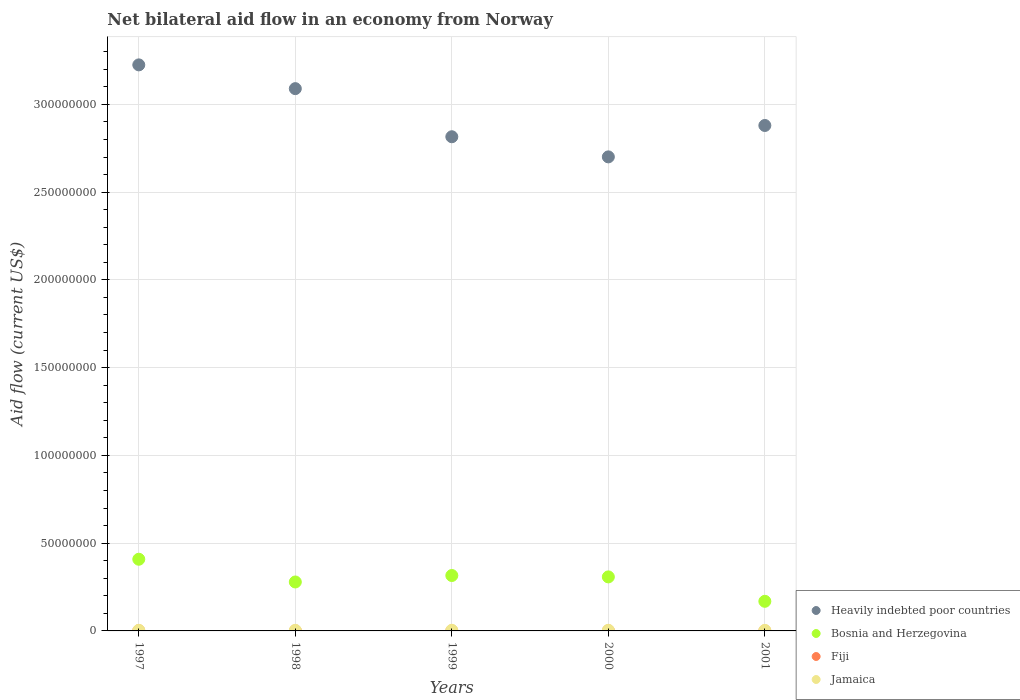How many different coloured dotlines are there?
Make the answer very short. 4. Is the number of dotlines equal to the number of legend labels?
Your answer should be compact. Yes. Across all years, what is the minimum net bilateral aid flow in Fiji?
Your answer should be compact. 2.00e+04. In which year was the net bilateral aid flow in Fiji maximum?
Your answer should be very brief. 1997. In which year was the net bilateral aid flow in Jamaica minimum?
Offer a very short reply. 2001. What is the difference between the net bilateral aid flow in Jamaica in 1997 and that in 1999?
Offer a very short reply. -2.00e+04. What is the difference between the net bilateral aid flow in Heavily indebted poor countries in 1999 and the net bilateral aid flow in Bosnia and Herzegovina in 2001?
Your response must be concise. 2.65e+08. What is the average net bilateral aid flow in Bosnia and Herzegovina per year?
Offer a terse response. 2.96e+07. In the year 2001, what is the difference between the net bilateral aid flow in Bosnia and Herzegovina and net bilateral aid flow in Heavily indebted poor countries?
Give a very brief answer. -2.71e+08. What is the ratio of the net bilateral aid flow in Jamaica in 1999 to that in 2001?
Provide a succinct answer. 1.16. Is the difference between the net bilateral aid flow in Bosnia and Herzegovina in 1998 and 1999 greater than the difference between the net bilateral aid flow in Heavily indebted poor countries in 1998 and 1999?
Your response must be concise. No. What is the difference between the highest and the second highest net bilateral aid flow in Heavily indebted poor countries?
Offer a terse response. 1.35e+07. What is the difference between the highest and the lowest net bilateral aid flow in Bosnia and Herzegovina?
Your response must be concise. 2.40e+07. Is it the case that in every year, the sum of the net bilateral aid flow in Jamaica and net bilateral aid flow in Heavily indebted poor countries  is greater than the sum of net bilateral aid flow in Fiji and net bilateral aid flow in Bosnia and Herzegovina?
Offer a very short reply. No. Is it the case that in every year, the sum of the net bilateral aid flow in Fiji and net bilateral aid flow in Bosnia and Herzegovina  is greater than the net bilateral aid flow in Heavily indebted poor countries?
Your response must be concise. No. Does the net bilateral aid flow in Bosnia and Herzegovina monotonically increase over the years?
Your answer should be compact. No. Is the net bilateral aid flow in Heavily indebted poor countries strictly greater than the net bilateral aid flow in Bosnia and Herzegovina over the years?
Offer a terse response. Yes. Is the net bilateral aid flow in Jamaica strictly less than the net bilateral aid flow in Heavily indebted poor countries over the years?
Offer a very short reply. Yes. How many dotlines are there?
Ensure brevity in your answer.  4. How many years are there in the graph?
Your answer should be very brief. 5. Does the graph contain grids?
Offer a very short reply. Yes. Where does the legend appear in the graph?
Offer a very short reply. Bottom right. What is the title of the graph?
Your response must be concise. Net bilateral aid flow in an economy from Norway. Does "Gambia, The" appear as one of the legend labels in the graph?
Your answer should be compact. No. What is the label or title of the X-axis?
Ensure brevity in your answer.  Years. What is the label or title of the Y-axis?
Make the answer very short. Aid flow (current US$). What is the Aid flow (current US$) in Heavily indebted poor countries in 1997?
Make the answer very short. 3.23e+08. What is the Aid flow (current US$) in Bosnia and Herzegovina in 1997?
Your answer should be compact. 4.08e+07. What is the Aid flow (current US$) in Fiji in 1997?
Give a very brief answer. 1.30e+05. What is the Aid flow (current US$) in Jamaica in 1997?
Ensure brevity in your answer.  3.40e+05. What is the Aid flow (current US$) in Heavily indebted poor countries in 1998?
Your answer should be compact. 3.09e+08. What is the Aid flow (current US$) of Bosnia and Herzegovina in 1998?
Your answer should be compact. 2.79e+07. What is the Aid flow (current US$) in Fiji in 1998?
Provide a short and direct response. 2.00e+04. What is the Aid flow (current US$) of Heavily indebted poor countries in 1999?
Offer a very short reply. 2.82e+08. What is the Aid flow (current US$) of Bosnia and Herzegovina in 1999?
Offer a very short reply. 3.16e+07. What is the Aid flow (current US$) in Fiji in 1999?
Ensure brevity in your answer.  2.00e+04. What is the Aid flow (current US$) of Jamaica in 1999?
Your response must be concise. 3.60e+05. What is the Aid flow (current US$) in Heavily indebted poor countries in 2000?
Make the answer very short. 2.70e+08. What is the Aid flow (current US$) of Bosnia and Herzegovina in 2000?
Your answer should be compact. 3.08e+07. What is the Aid flow (current US$) in Fiji in 2000?
Your response must be concise. 1.00e+05. What is the Aid flow (current US$) of Heavily indebted poor countries in 2001?
Keep it short and to the point. 2.88e+08. What is the Aid flow (current US$) of Bosnia and Herzegovina in 2001?
Your response must be concise. 1.69e+07. Across all years, what is the maximum Aid flow (current US$) in Heavily indebted poor countries?
Offer a terse response. 3.23e+08. Across all years, what is the maximum Aid flow (current US$) in Bosnia and Herzegovina?
Provide a short and direct response. 4.08e+07. Across all years, what is the maximum Aid flow (current US$) in Fiji?
Your answer should be compact. 1.30e+05. Across all years, what is the maximum Aid flow (current US$) of Jamaica?
Keep it short and to the point. 3.60e+05. Across all years, what is the minimum Aid flow (current US$) of Heavily indebted poor countries?
Make the answer very short. 2.70e+08. Across all years, what is the minimum Aid flow (current US$) of Bosnia and Herzegovina?
Offer a terse response. 1.69e+07. Across all years, what is the minimum Aid flow (current US$) of Jamaica?
Make the answer very short. 3.10e+05. What is the total Aid flow (current US$) in Heavily indebted poor countries in the graph?
Offer a very short reply. 1.47e+09. What is the total Aid flow (current US$) in Bosnia and Herzegovina in the graph?
Make the answer very short. 1.48e+08. What is the total Aid flow (current US$) of Jamaica in the graph?
Provide a short and direct response. 1.71e+06. What is the difference between the Aid flow (current US$) in Heavily indebted poor countries in 1997 and that in 1998?
Your response must be concise. 1.35e+07. What is the difference between the Aid flow (current US$) of Bosnia and Herzegovina in 1997 and that in 1998?
Your answer should be very brief. 1.30e+07. What is the difference between the Aid flow (current US$) in Fiji in 1997 and that in 1998?
Your answer should be very brief. 1.10e+05. What is the difference between the Aid flow (current US$) of Jamaica in 1997 and that in 1998?
Ensure brevity in your answer.  0. What is the difference between the Aid flow (current US$) in Heavily indebted poor countries in 1997 and that in 1999?
Give a very brief answer. 4.10e+07. What is the difference between the Aid flow (current US$) of Bosnia and Herzegovina in 1997 and that in 1999?
Ensure brevity in your answer.  9.27e+06. What is the difference between the Aid flow (current US$) of Heavily indebted poor countries in 1997 and that in 2000?
Provide a short and direct response. 5.24e+07. What is the difference between the Aid flow (current US$) in Bosnia and Herzegovina in 1997 and that in 2000?
Your response must be concise. 1.01e+07. What is the difference between the Aid flow (current US$) in Fiji in 1997 and that in 2000?
Provide a succinct answer. 3.00e+04. What is the difference between the Aid flow (current US$) of Jamaica in 1997 and that in 2000?
Make the answer very short. -2.00e+04. What is the difference between the Aid flow (current US$) in Heavily indebted poor countries in 1997 and that in 2001?
Keep it short and to the point. 3.45e+07. What is the difference between the Aid flow (current US$) in Bosnia and Herzegovina in 1997 and that in 2001?
Keep it short and to the point. 2.40e+07. What is the difference between the Aid flow (current US$) in Jamaica in 1997 and that in 2001?
Offer a terse response. 3.00e+04. What is the difference between the Aid flow (current US$) of Heavily indebted poor countries in 1998 and that in 1999?
Keep it short and to the point. 2.74e+07. What is the difference between the Aid flow (current US$) of Bosnia and Herzegovina in 1998 and that in 1999?
Your response must be concise. -3.68e+06. What is the difference between the Aid flow (current US$) in Fiji in 1998 and that in 1999?
Offer a very short reply. 0. What is the difference between the Aid flow (current US$) in Jamaica in 1998 and that in 1999?
Your response must be concise. -2.00e+04. What is the difference between the Aid flow (current US$) of Heavily indebted poor countries in 1998 and that in 2000?
Give a very brief answer. 3.89e+07. What is the difference between the Aid flow (current US$) in Bosnia and Herzegovina in 1998 and that in 2000?
Your response must be concise. -2.89e+06. What is the difference between the Aid flow (current US$) in Fiji in 1998 and that in 2000?
Ensure brevity in your answer.  -8.00e+04. What is the difference between the Aid flow (current US$) in Jamaica in 1998 and that in 2000?
Your answer should be compact. -2.00e+04. What is the difference between the Aid flow (current US$) in Heavily indebted poor countries in 1998 and that in 2001?
Your answer should be very brief. 2.10e+07. What is the difference between the Aid flow (current US$) of Bosnia and Herzegovina in 1998 and that in 2001?
Your answer should be very brief. 1.10e+07. What is the difference between the Aid flow (current US$) of Heavily indebted poor countries in 1999 and that in 2000?
Make the answer very short. 1.15e+07. What is the difference between the Aid flow (current US$) in Bosnia and Herzegovina in 1999 and that in 2000?
Your answer should be very brief. 7.90e+05. What is the difference between the Aid flow (current US$) of Fiji in 1999 and that in 2000?
Offer a very short reply. -8.00e+04. What is the difference between the Aid flow (current US$) in Jamaica in 1999 and that in 2000?
Provide a short and direct response. 0. What is the difference between the Aid flow (current US$) in Heavily indebted poor countries in 1999 and that in 2001?
Give a very brief answer. -6.42e+06. What is the difference between the Aid flow (current US$) in Bosnia and Herzegovina in 1999 and that in 2001?
Make the answer very short. 1.47e+07. What is the difference between the Aid flow (current US$) of Jamaica in 1999 and that in 2001?
Offer a terse response. 5.00e+04. What is the difference between the Aid flow (current US$) of Heavily indebted poor countries in 2000 and that in 2001?
Provide a succinct answer. -1.79e+07. What is the difference between the Aid flow (current US$) in Bosnia and Herzegovina in 2000 and that in 2001?
Make the answer very short. 1.39e+07. What is the difference between the Aid flow (current US$) of Heavily indebted poor countries in 1997 and the Aid flow (current US$) of Bosnia and Herzegovina in 1998?
Your answer should be compact. 2.95e+08. What is the difference between the Aid flow (current US$) in Heavily indebted poor countries in 1997 and the Aid flow (current US$) in Fiji in 1998?
Offer a terse response. 3.22e+08. What is the difference between the Aid flow (current US$) in Heavily indebted poor countries in 1997 and the Aid flow (current US$) in Jamaica in 1998?
Your answer should be very brief. 3.22e+08. What is the difference between the Aid flow (current US$) in Bosnia and Herzegovina in 1997 and the Aid flow (current US$) in Fiji in 1998?
Offer a terse response. 4.08e+07. What is the difference between the Aid flow (current US$) in Bosnia and Herzegovina in 1997 and the Aid flow (current US$) in Jamaica in 1998?
Give a very brief answer. 4.05e+07. What is the difference between the Aid flow (current US$) of Fiji in 1997 and the Aid flow (current US$) of Jamaica in 1998?
Offer a terse response. -2.10e+05. What is the difference between the Aid flow (current US$) of Heavily indebted poor countries in 1997 and the Aid flow (current US$) of Bosnia and Herzegovina in 1999?
Offer a very short reply. 2.91e+08. What is the difference between the Aid flow (current US$) in Heavily indebted poor countries in 1997 and the Aid flow (current US$) in Fiji in 1999?
Provide a short and direct response. 3.22e+08. What is the difference between the Aid flow (current US$) in Heavily indebted poor countries in 1997 and the Aid flow (current US$) in Jamaica in 1999?
Give a very brief answer. 3.22e+08. What is the difference between the Aid flow (current US$) in Bosnia and Herzegovina in 1997 and the Aid flow (current US$) in Fiji in 1999?
Your response must be concise. 4.08e+07. What is the difference between the Aid flow (current US$) of Bosnia and Herzegovina in 1997 and the Aid flow (current US$) of Jamaica in 1999?
Keep it short and to the point. 4.05e+07. What is the difference between the Aid flow (current US$) in Fiji in 1997 and the Aid flow (current US$) in Jamaica in 1999?
Provide a succinct answer. -2.30e+05. What is the difference between the Aid flow (current US$) in Heavily indebted poor countries in 1997 and the Aid flow (current US$) in Bosnia and Herzegovina in 2000?
Make the answer very short. 2.92e+08. What is the difference between the Aid flow (current US$) in Heavily indebted poor countries in 1997 and the Aid flow (current US$) in Fiji in 2000?
Provide a short and direct response. 3.22e+08. What is the difference between the Aid flow (current US$) in Heavily indebted poor countries in 1997 and the Aid flow (current US$) in Jamaica in 2000?
Ensure brevity in your answer.  3.22e+08. What is the difference between the Aid flow (current US$) in Bosnia and Herzegovina in 1997 and the Aid flow (current US$) in Fiji in 2000?
Your answer should be compact. 4.07e+07. What is the difference between the Aid flow (current US$) of Bosnia and Herzegovina in 1997 and the Aid flow (current US$) of Jamaica in 2000?
Keep it short and to the point. 4.05e+07. What is the difference between the Aid flow (current US$) of Fiji in 1997 and the Aid flow (current US$) of Jamaica in 2000?
Offer a very short reply. -2.30e+05. What is the difference between the Aid flow (current US$) in Heavily indebted poor countries in 1997 and the Aid flow (current US$) in Bosnia and Herzegovina in 2001?
Ensure brevity in your answer.  3.06e+08. What is the difference between the Aid flow (current US$) in Heavily indebted poor countries in 1997 and the Aid flow (current US$) in Fiji in 2001?
Keep it short and to the point. 3.22e+08. What is the difference between the Aid flow (current US$) in Heavily indebted poor countries in 1997 and the Aid flow (current US$) in Jamaica in 2001?
Offer a terse response. 3.22e+08. What is the difference between the Aid flow (current US$) of Bosnia and Herzegovina in 1997 and the Aid flow (current US$) of Fiji in 2001?
Your answer should be very brief. 4.08e+07. What is the difference between the Aid flow (current US$) of Bosnia and Herzegovina in 1997 and the Aid flow (current US$) of Jamaica in 2001?
Your answer should be very brief. 4.05e+07. What is the difference between the Aid flow (current US$) of Fiji in 1997 and the Aid flow (current US$) of Jamaica in 2001?
Provide a succinct answer. -1.80e+05. What is the difference between the Aid flow (current US$) of Heavily indebted poor countries in 1998 and the Aid flow (current US$) of Bosnia and Herzegovina in 1999?
Give a very brief answer. 2.77e+08. What is the difference between the Aid flow (current US$) of Heavily indebted poor countries in 1998 and the Aid flow (current US$) of Fiji in 1999?
Offer a terse response. 3.09e+08. What is the difference between the Aid flow (current US$) in Heavily indebted poor countries in 1998 and the Aid flow (current US$) in Jamaica in 1999?
Give a very brief answer. 3.09e+08. What is the difference between the Aid flow (current US$) in Bosnia and Herzegovina in 1998 and the Aid flow (current US$) in Fiji in 1999?
Offer a very short reply. 2.79e+07. What is the difference between the Aid flow (current US$) in Bosnia and Herzegovina in 1998 and the Aid flow (current US$) in Jamaica in 1999?
Provide a short and direct response. 2.75e+07. What is the difference between the Aid flow (current US$) of Fiji in 1998 and the Aid flow (current US$) of Jamaica in 1999?
Offer a terse response. -3.40e+05. What is the difference between the Aid flow (current US$) in Heavily indebted poor countries in 1998 and the Aid flow (current US$) in Bosnia and Herzegovina in 2000?
Keep it short and to the point. 2.78e+08. What is the difference between the Aid flow (current US$) of Heavily indebted poor countries in 1998 and the Aid flow (current US$) of Fiji in 2000?
Give a very brief answer. 3.09e+08. What is the difference between the Aid flow (current US$) in Heavily indebted poor countries in 1998 and the Aid flow (current US$) in Jamaica in 2000?
Offer a terse response. 3.09e+08. What is the difference between the Aid flow (current US$) in Bosnia and Herzegovina in 1998 and the Aid flow (current US$) in Fiji in 2000?
Your answer should be very brief. 2.78e+07. What is the difference between the Aid flow (current US$) of Bosnia and Herzegovina in 1998 and the Aid flow (current US$) of Jamaica in 2000?
Your response must be concise. 2.75e+07. What is the difference between the Aid flow (current US$) of Heavily indebted poor countries in 1998 and the Aid flow (current US$) of Bosnia and Herzegovina in 2001?
Your response must be concise. 2.92e+08. What is the difference between the Aid flow (current US$) in Heavily indebted poor countries in 1998 and the Aid flow (current US$) in Fiji in 2001?
Make the answer very short. 3.09e+08. What is the difference between the Aid flow (current US$) of Heavily indebted poor countries in 1998 and the Aid flow (current US$) of Jamaica in 2001?
Make the answer very short. 3.09e+08. What is the difference between the Aid flow (current US$) in Bosnia and Herzegovina in 1998 and the Aid flow (current US$) in Fiji in 2001?
Your answer should be compact. 2.79e+07. What is the difference between the Aid flow (current US$) of Bosnia and Herzegovina in 1998 and the Aid flow (current US$) of Jamaica in 2001?
Your response must be concise. 2.76e+07. What is the difference between the Aid flow (current US$) of Heavily indebted poor countries in 1999 and the Aid flow (current US$) of Bosnia and Herzegovina in 2000?
Give a very brief answer. 2.51e+08. What is the difference between the Aid flow (current US$) in Heavily indebted poor countries in 1999 and the Aid flow (current US$) in Fiji in 2000?
Offer a very short reply. 2.81e+08. What is the difference between the Aid flow (current US$) of Heavily indebted poor countries in 1999 and the Aid flow (current US$) of Jamaica in 2000?
Keep it short and to the point. 2.81e+08. What is the difference between the Aid flow (current US$) in Bosnia and Herzegovina in 1999 and the Aid flow (current US$) in Fiji in 2000?
Provide a succinct answer. 3.15e+07. What is the difference between the Aid flow (current US$) of Bosnia and Herzegovina in 1999 and the Aid flow (current US$) of Jamaica in 2000?
Give a very brief answer. 3.12e+07. What is the difference between the Aid flow (current US$) in Fiji in 1999 and the Aid flow (current US$) in Jamaica in 2000?
Offer a terse response. -3.40e+05. What is the difference between the Aid flow (current US$) of Heavily indebted poor countries in 1999 and the Aid flow (current US$) of Bosnia and Herzegovina in 2001?
Give a very brief answer. 2.65e+08. What is the difference between the Aid flow (current US$) of Heavily indebted poor countries in 1999 and the Aid flow (current US$) of Fiji in 2001?
Ensure brevity in your answer.  2.82e+08. What is the difference between the Aid flow (current US$) in Heavily indebted poor countries in 1999 and the Aid flow (current US$) in Jamaica in 2001?
Offer a terse response. 2.81e+08. What is the difference between the Aid flow (current US$) of Bosnia and Herzegovina in 1999 and the Aid flow (current US$) of Fiji in 2001?
Provide a succinct answer. 3.16e+07. What is the difference between the Aid flow (current US$) in Bosnia and Herzegovina in 1999 and the Aid flow (current US$) in Jamaica in 2001?
Provide a succinct answer. 3.13e+07. What is the difference between the Aid flow (current US$) in Fiji in 1999 and the Aid flow (current US$) in Jamaica in 2001?
Give a very brief answer. -2.90e+05. What is the difference between the Aid flow (current US$) of Heavily indebted poor countries in 2000 and the Aid flow (current US$) of Bosnia and Herzegovina in 2001?
Make the answer very short. 2.53e+08. What is the difference between the Aid flow (current US$) in Heavily indebted poor countries in 2000 and the Aid flow (current US$) in Fiji in 2001?
Offer a terse response. 2.70e+08. What is the difference between the Aid flow (current US$) in Heavily indebted poor countries in 2000 and the Aid flow (current US$) in Jamaica in 2001?
Keep it short and to the point. 2.70e+08. What is the difference between the Aid flow (current US$) of Bosnia and Herzegovina in 2000 and the Aid flow (current US$) of Fiji in 2001?
Your response must be concise. 3.08e+07. What is the difference between the Aid flow (current US$) in Bosnia and Herzegovina in 2000 and the Aid flow (current US$) in Jamaica in 2001?
Offer a very short reply. 3.05e+07. What is the average Aid flow (current US$) in Heavily indebted poor countries per year?
Make the answer very short. 2.94e+08. What is the average Aid flow (current US$) in Bosnia and Herzegovina per year?
Provide a succinct answer. 2.96e+07. What is the average Aid flow (current US$) in Fiji per year?
Ensure brevity in your answer.  5.80e+04. What is the average Aid flow (current US$) of Jamaica per year?
Offer a very short reply. 3.42e+05. In the year 1997, what is the difference between the Aid flow (current US$) of Heavily indebted poor countries and Aid flow (current US$) of Bosnia and Herzegovina?
Keep it short and to the point. 2.82e+08. In the year 1997, what is the difference between the Aid flow (current US$) in Heavily indebted poor countries and Aid flow (current US$) in Fiji?
Your answer should be compact. 3.22e+08. In the year 1997, what is the difference between the Aid flow (current US$) in Heavily indebted poor countries and Aid flow (current US$) in Jamaica?
Offer a very short reply. 3.22e+08. In the year 1997, what is the difference between the Aid flow (current US$) of Bosnia and Herzegovina and Aid flow (current US$) of Fiji?
Make the answer very short. 4.07e+07. In the year 1997, what is the difference between the Aid flow (current US$) of Bosnia and Herzegovina and Aid flow (current US$) of Jamaica?
Ensure brevity in your answer.  4.05e+07. In the year 1997, what is the difference between the Aid flow (current US$) of Fiji and Aid flow (current US$) of Jamaica?
Offer a very short reply. -2.10e+05. In the year 1998, what is the difference between the Aid flow (current US$) of Heavily indebted poor countries and Aid flow (current US$) of Bosnia and Herzegovina?
Keep it short and to the point. 2.81e+08. In the year 1998, what is the difference between the Aid flow (current US$) of Heavily indebted poor countries and Aid flow (current US$) of Fiji?
Your answer should be very brief. 3.09e+08. In the year 1998, what is the difference between the Aid flow (current US$) of Heavily indebted poor countries and Aid flow (current US$) of Jamaica?
Offer a very short reply. 3.09e+08. In the year 1998, what is the difference between the Aid flow (current US$) of Bosnia and Herzegovina and Aid flow (current US$) of Fiji?
Make the answer very short. 2.79e+07. In the year 1998, what is the difference between the Aid flow (current US$) in Bosnia and Herzegovina and Aid flow (current US$) in Jamaica?
Ensure brevity in your answer.  2.76e+07. In the year 1998, what is the difference between the Aid flow (current US$) of Fiji and Aid flow (current US$) of Jamaica?
Your response must be concise. -3.20e+05. In the year 1999, what is the difference between the Aid flow (current US$) of Heavily indebted poor countries and Aid flow (current US$) of Bosnia and Herzegovina?
Provide a short and direct response. 2.50e+08. In the year 1999, what is the difference between the Aid flow (current US$) in Heavily indebted poor countries and Aid flow (current US$) in Fiji?
Ensure brevity in your answer.  2.82e+08. In the year 1999, what is the difference between the Aid flow (current US$) of Heavily indebted poor countries and Aid flow (current US$) of Jamaica?
Your answer should be compact. 2.81e+08. In the year 1999, what is the difference between the Aid flow (current US$) of Bosnia and Herzegovina and Aid flow (current US$) of Fiji?
Provide a short and direct response. 3.16e+07. In the year 1999, what is the difference between the Aid flow (current US$) of Bosnia and Herzegovina and Aid flow (current US$) of Jamaica?
Provide a short and direct response. 3.12e+07. In the year 2000, what is the difference between the Aid flow (current US$) in Heavily indebted poor countries and Aid flow (current US$) in Bosnia and Herzegovina?
Your response must be concise. 2.39e+08. In the year 2000, what is the difference between the Aid flow (current US$) in Heavily indebted poor countries and Aid flow (current US$) in Fiji?
Offer a terse response. 2.70e+08. In the year 2000, what is the difference between the Aid flow (current US$) in Heavily indebted poor countries and Aid flow (current US$) in Jamaica?
Your answer should be compact. 2.70e+08. In the year 2000, what is the difference between the Aid flow (current US$) of Bosnia and Herzegovina and Aid flow (current US$) of Fiji?
Make the answer very short. 3.07e+07. In the year 2000, what is the difference between the Aid flow (current US$) in Bosnia and Herzegovina and Aid flow (current US$) in Jamaica?
Make the answer very short. 3.04e+07. In the year 2000, what is the difference between the Aid flow (current US$) of Fiji and Aid flow (current US$) of Jamaica?
Offer a terse response. -2.60e+05. In the year 2001, what is the difference between the Aid flow (current US$) in Heavily indebted poor countries and Aid flow (current US$) in Bosnia and Herzegovina?
Give a very brief answer. 2.71e+08. In the year 2001, what is the difference between the Aid flow (current US$) of Heavily indebted poor countries and Aid flow (current US$) of Fiji?
Give a very brief answer. 2.88e+08. In the year 2001, what is the difference between the Aid flow (current US$) of Heavily indebted poor countries and Aid flow (current US$) of Jamaica?
Make the answer very short. 2.88e+08. In the year 2001, what is the difference between the Aid flow (current US$) of Bosnia and Herzegovina and Aid flow (current US$) of Fiji?
Your response must be concise. 1.68e+07. In the year 2001, what is the difference between the Aid flow (current US$) of Bosnia and Herzegovina and Aid flow (current US$) of Jamaica?
Your answer should be compact. 1.66e+07. What is the ratio of the Aid flow (current US$) of Heavily indebted poor countries in 1997 to that in 1998?
Your response must be concise. 1.04. What is the ratio of the Aid flow (current US$) of Bosnia and Herzegovina in 1997 to that in 1998?
Your response must be concise. 1.46. What is the ratio of the Aid flow (current US$) in Heavily indebted poor countries in 1997 to that in 1999?
Provide a short and direct response. 1.15. What is the ratio of the Aid flow (current US$) in Bosnia and Herzegovina in 1997 to that in 1999?
Give a very brief answer. 1.29. What is the ratio of the Aid flow (current US$) of Fiji in 1997 to that in 1999?
Provide a succinct answer. 6.5. What is the ratio of the Aid flow (current US$) of Heavily indebted poor countries in 1997 to that in 2000?
Ensure brevity in your answer.  1.19. What is the ratio of the Aid flow (current US$) of Bosnia and Herzegovina in 1997 to that in 2000?
Keep it short and to the point. 1.33. What is the ratio of the Aid flow (current US$) in Fiji in 1997 to that in 2000?
Give a very brief answer. 1.3. What is the ratio of the Aid flow (current US$) of Jamaica in 1997 to that in 2000?
Ensure brevity in your answer.  0.94. What is the ratio of the Aid flow (current US$) in Heavily indebted poor countries in 1997 to that in 2001?
Offer a terse response. 1.12. What is the ratio of the Aid flow (current US$) in Bosnia and Herzegovina in 1997 to that in 2001?
Keep it short and to the point. 2.42. What is the ratio of the Aid flow (current US$) in Jamaica in 1997 to that in 2001?
Make the answer very short. 1.1. What is the ratio of the Aid flow (current US$) in Heavily indebted poor countries in 1998 to that in 1999?
Ensure brevity in your answer.  1.1. What is the ratio of the Aid flow (current US$) in Bosnia and Herzegovina in 1998 to that in 1999?
Give a very brief answer. 0.88. What is the ratio of the Aid flow (current US$) of Heavily indebted poor countries in 1998 to that in 2000?
Give a very brief answer. 1.14. What is the ratio of the Aid flow (current US$) in Bosnia and Herzegovina in 1998 to that in 2000?
Keep it short and to the point. 0.91. What is the ratio of the Aid flow (current US$) in Fiji in 1998 to that in 2000?
Give a very brief answer. 0.2. What is the ratio of the Aid flow (current US$) of Heavily indebted poor countries in 1998 to that in 2001?
Your answer should be compact. 1.07. What is the ratio of the Aid flow (current US$) in Bosnia and Herzegovina in 1998 to that in 2001?
Your answer should be very brief. 1.65. What is the ratio of the Aid flow (current US$) in Fiji in 1998 to that in 2001?
Give a very brief answer. 1. What is the ratio of the Aid flow (current US$) of Jamaica in 1998 to that in 2001?
Your answer should be very brief. 1.1. What is the ratio of the Aid flow (current US$) in Heavily indebted poor countries in 1999 to that in 2000?
Give a very brief answer. 1.04. What is the ratio of the Aid flow (current US$) in Bosnia and Herzegovina in 1999 to that in 2000?
Ensure brevity in your answer.  1.03. What is the ratio of the Aid flow (current US$) of Fiji in 1999 to that in 2000?
Give a very brief answer. 0.2. What is the ratio of the Aid flow (current US$) in Heavily indebted poor countries in 1999 to that in 2001?
Provide a short and direct response. 0.98. What is the ratio of the Aid flow (current US$) of Bosnia and Herzegovina in 1999 to that in 2001?
Provide a succinct answer. 1.87. What is the ratio of the Aid flow (current US$) in Jamaica in 1999 to that in 2001?
Your response must be concise. 1.16. What is the ratio of the Aid flow (current US$) of Heavily indebted poor countries in 2000 to that in 2001?
Give a very brief answer. 0.94. What is the ratio of the Aid flow (current US$) of Bosnia and Herzegovina in 2000 to that in 2001?
Make the answer very short. 1.82. What is the ratio of the Aid flow (current US$) of Fiji in 2000 to that in 2001?
Offer a very short reply. 5. What is the ratio of the Aid flow (current US$) of Jamaica in 2000 to that in 2001?
Make the answer very short. 1.16. What is the difference between the highest and the second highest Aid flow (current US$) of Heavily indebted poor countries?
Provide a short and direct response. 1.35e+07. What is the difference between the highest and the second highest Aid flow (current US$) in Bosnia and Herzegovina?
Your response must be concise. 9.27e+06. What is the difference between the highest and the second highest Aid flow (current US$) in Fiji?
Offer a terse response. 3.00e+04. What is the difference between the highest and the second highest Aid flow (current US$) of Jamaica?
Offer a very short reply. 0. What is the difference between the highest and the lowest Aid flow (current US$) in Heavily indebted poor countries?
Your answer should be very brief. 5.24e+07. What is the difference between the highest and the lowest Aid flow (current US$) in Bosnia and Herzegovina?
Offer a terse response. 2.40e+07. What is the difference between the highest and the lowest Aid flow (current US$) of Fiji?
Provide a succinct answer. 1.10e+05. What is the difference between the highest and the lowest Aid flow (current US$) of Jamaica?
Your response must be concise. 5.00e+04. 